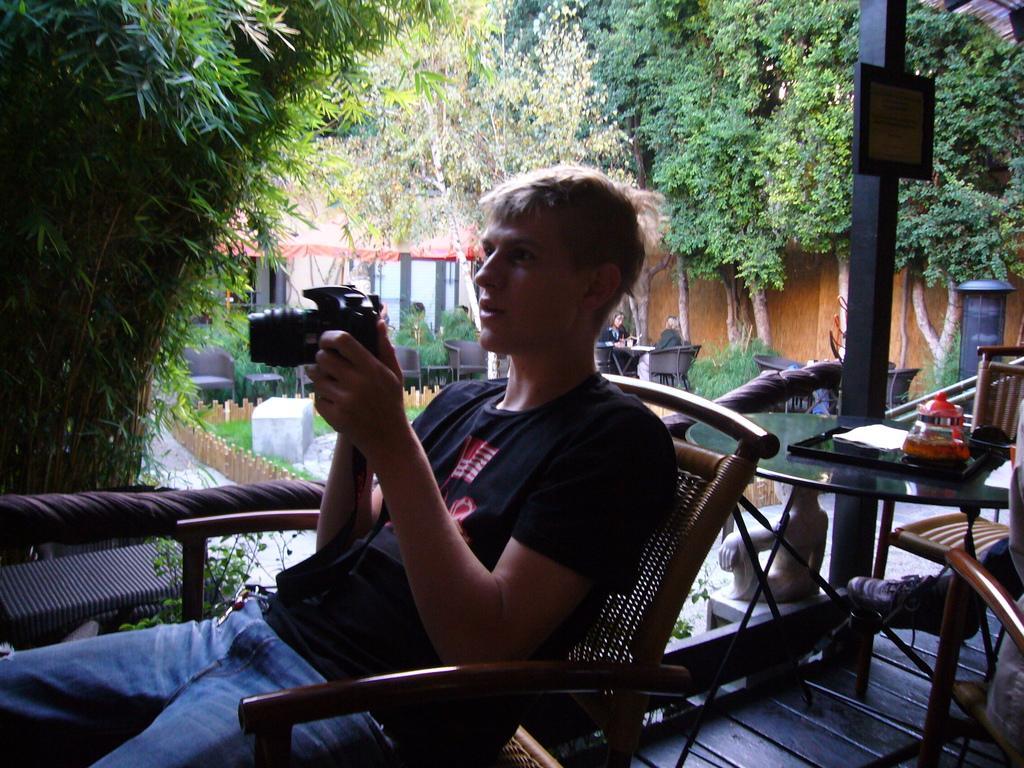Please provide a concise description of this image. In this image a man sitting on a chair and holding camera in his hands, behind him there is a table, on that table there is a plate, in the background there is a chair two persons are sitting on chairs and there are trees. 